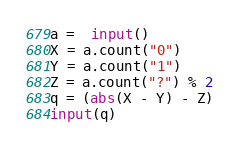<code> <loc_0><loc_0><loc_500><loc_500><_Python_>a =  input()
X = a.count("0")
Y = a.count("1")
Z = a.count("?") % 2
q = (abs(X - Y) - Z)
input(q)</code> 